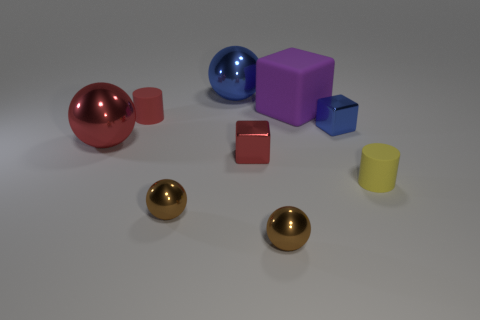There is a large purple thing that is the same shape as the small blue object; what material is it?
Offer a very short reply. Rubber. What color is the object that is both to the left of the big blue object and behind the tiny blue metal cube?
Make the answer very short. Red. The large rubber cube is what color?
Make the answer very short. Purple. Is there a red matte object of the same shape as the yellow rubber thing?
Keep it short and to the point. Yes. What is the size of the cylinder left of the yellow cylinder?
Your response must be concise. Small. There is a purple thing that is the same size as the blue sphere; what is it made of?
Offer a very short reply. Rubber. Is the number of red matte things greater than the number of tiny gray rubber blocks?
Keep it short and to the point. Yes. There is a brown metal ball that is on the right side of the small shiny block left of the tiny blue cube; what is its size?
Give a very brief answer. Small. The yellow matte object that is the same size as the red matte thing is what shape?
Make the answer very short. Cylinder. What is the shape of the blue thing behind the large purple rubber cube on the left side of the cube that is on the right side of the purple thing?
Provide a succinct answer. Sphere. 